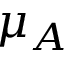Convert formula to latex. <formula><loc_0><loc_0><loc_500><loc_500>\mu _ { A }</formula> 